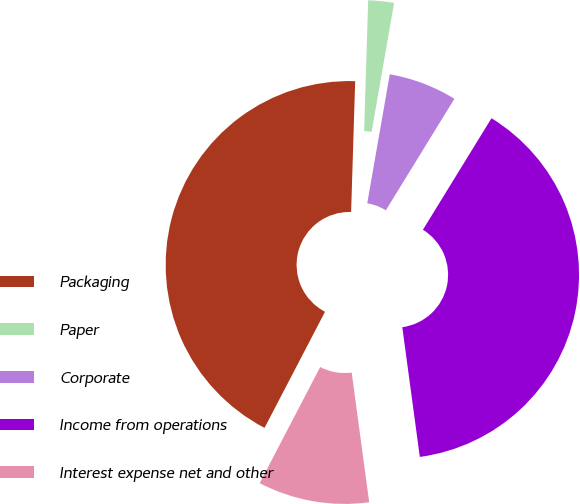<chart> <loc_0><loc_0><loc_500><loc_500><pie_chart><fcel>Packaging<fcel>Paper<fcel>Corporate<fcel>Income from operations<fcel>Interest expense net and other<nl><fcel>42.85%<fcel>2.26%<fcel>6.02%<fcel>39.09%<fcel>9.78%<nl></chart> 